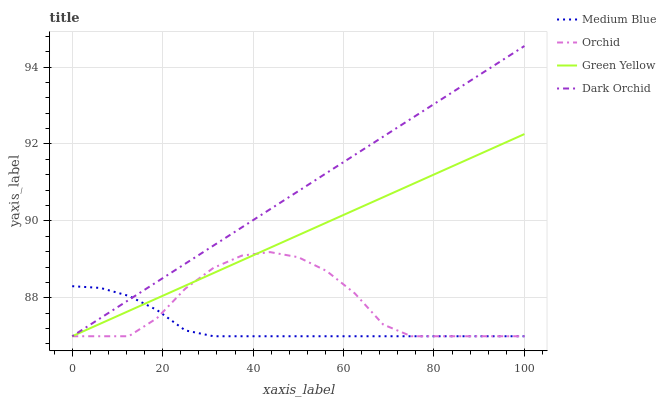Does Dark Orchid have the minimum area under the curve?
Answer yes or no. No. Does Medium Blue have the maximum area under the curve?
Answer yes or no. No. Is Medium Blue the smoothest?
Answer yes or no. No. Is Medium Blue the roughest?
Answer yes or no. No. Does Medium Blue have the highest value?
Answer yes or no. No. 